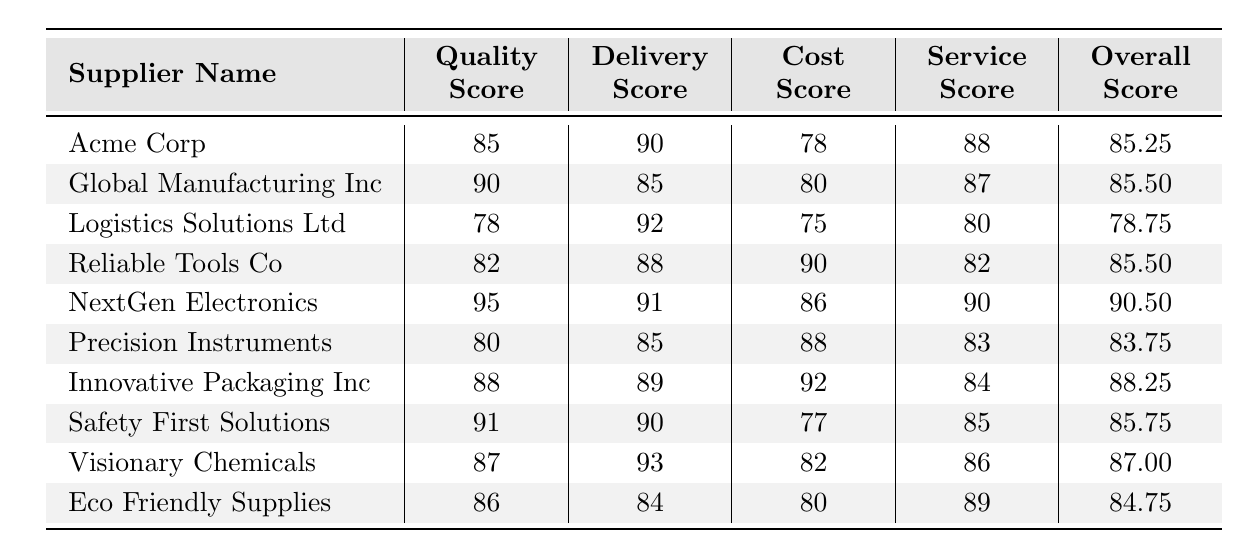What is the Overall Score for NextGen Electronics? The Overall Score for NextGen Electronics is listed directly in the table under the Overall Score column, which shows a value of 90.5.
Answer: 90.5 Which supplier has the highest Quality Score? NextGen Electronics has the highest Quality Score of 95, as shown in the Quality Score column.
Answer: NextGen Electronics What is the average Cost Score of all suppliers? To compute the average Cost Score, add all the Cost Scores: (78 + 80 + 75 + 90 + 86 + 88 + 92 + 77 + 82 + 80) =  856. There are 10 suppliers, so the average is 856 / 10 = 85.6.
Answer: 85.6 Does Eco Friendly Supplies have an Overall Score greater than 85? The Overall Score for Eco Friendly Supplies is 84.75, which is less than 85. Therefore, the statement is false.
Answer: No Which supplier has the lowest Overall Score? Logistics Solutions Ltd has the lowest Overall Score of 78.75, as this value is the smallest in the Overall Score column.
Answer: Logistics Solutions Ltd What is the difference between the Quality Score of Visionary Chemicals and Logistics Solutions Ltd? Visionary Chemicals has a Quality Score of 87, and Logistics Solutions Ltd has a Quality Score of 78. The difference is calculated by subtracting 78 from 87, which equals 9.
Answer: 9 Is Safety First Solutions rated higher in Service Score than Acme Corp? Safety First Solutions has a Service Score of 85, while Acme Corp has a Service Score of 88. Since 85 is less than 88, the statement is false.
Answer: No What is the median Overall Score of all suppliers? To find the median, list the Overall Scores in order: 78.75, 83.75, 84.75, 85.25, 85.5, 85.5, 85.75, 87, 88.25, 90.5. There are 10 values, so the median is the average of the 5th and 6th scores: (85.5 + 85.5) / 2 = 85.5.
Answer: 85.5 Which supplier scored the highest in Delivery Score, and what is that score? The Delivery Score column shows that Visionary Chemicals has the highest Delivery Score of 93.
Answer: Visionary Chemicals, 93 Which supplier has the lowest Service Score? The lowest Service Score is found by checking the Service Score column, which shows that Reliable Tools Co has a Service Score of 82.
Answer: Reliable Tools Co 